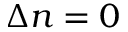Convert formula to latex. <formula><loc_0><loc_0><loc_500><loc_500>\Delta n = 0</formula> 